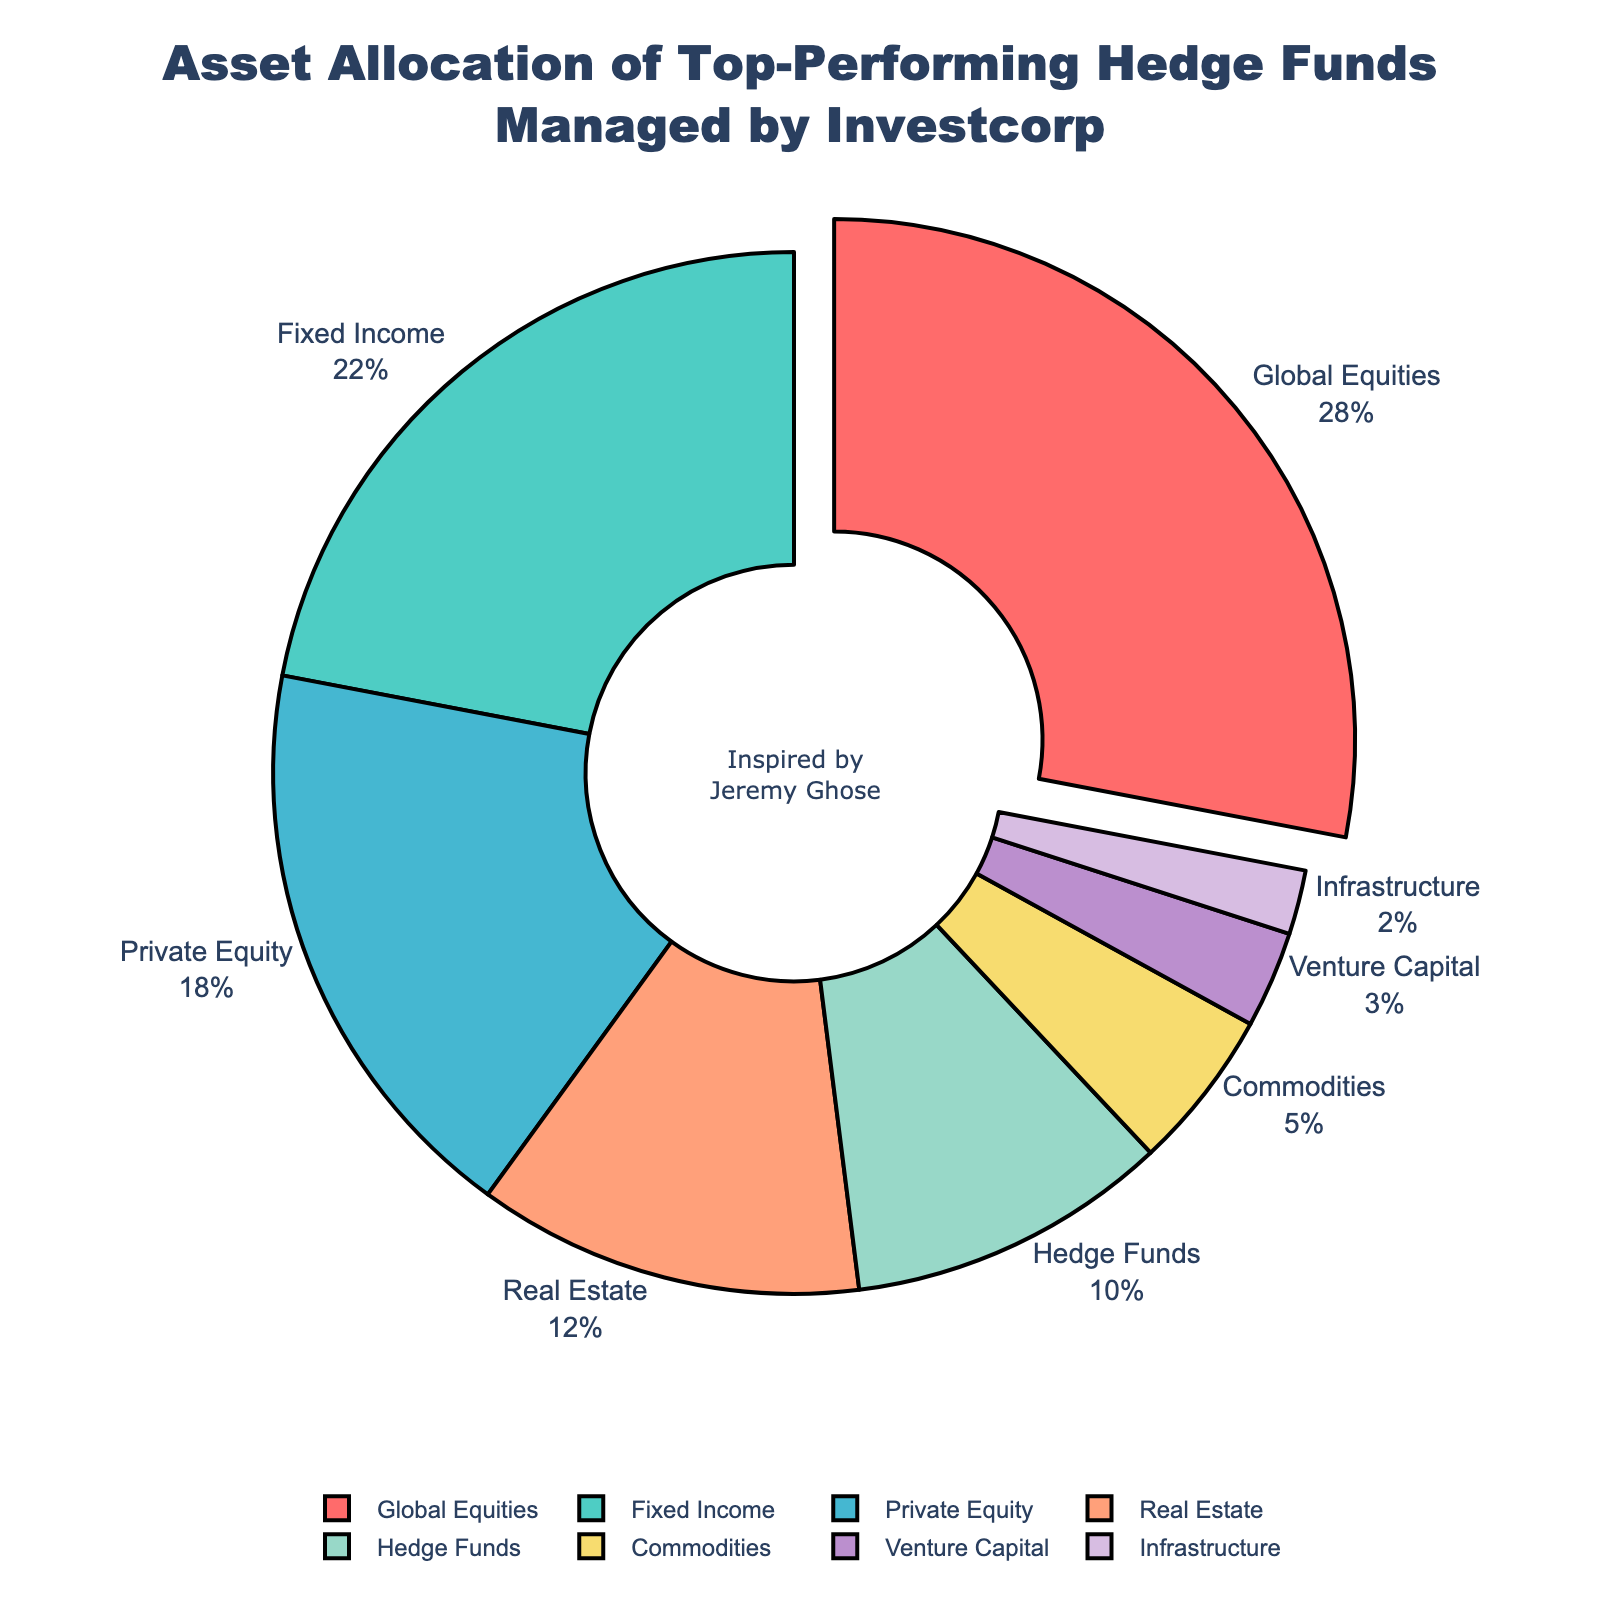What percentage of assets is allocated to the two largest asset classes? The two largest asset classes are Global Equities (28%) and Fixed Income (22%). Adding these percentages gives 28 + 22 = 50%.
Answer: 50% Which asset class has the smallest allocation, and what is the percentage? The smallest allocation is given to Infrastructure, which is 2%.
Answer: Infrastructure, 2% How much more is the percentage allocation to Real Estate than to Commodities? The percentage allocation to Real Estate is 12%, and to Commodities is 5%. The difference is 12 - 5 = 7%.
Answer: 7% Which asset classes are allocated exactly double or more the percentage of Hedge Funds? Hedge Funds are allocated 10%. The asset classes with double or more are Global Equities (28%), Fixed Income (22%), and Private Equity (18%) because all these percentages are more than 20%, which is double 10%.
Answer: Global Equities, Fixed Income, Private Equity Summing the allocations of Venture Capital and Infrastructure, how does it compare to the allocation for Private Equity? Venture Capital is 3% and Infrastructure is 2%, making their sum 3 + 2 = 5%. Private Equity has an allocation of 18%. 5% is less than 18%.
Answer: Less What color represents the asset class with the largest percentage allocation? The pie chart shows that the asset class with the largest allocation is Global Equities, which is represented by the color red.
Answer: Red What is the combined percentage allocation of asset classes other than Global Equities and Fixed Income? Excluding Global Equities (28%) and Fixed Income (22%), the remaining allocations are 18% (Private Equity) + 12% (Real Estate) + 10% (Hedge Funds) + 5% (Commodities) + 3% (Venture Capital) + 2% (Infrastructure) = 50%.
Answer: 50% What is the visual effect applied to indicate the asset class with the largest allocation? The asset class with the largest allocation, which is Global Equities, is pulled out slightly from the rest of the pie chart segments.
Answer: Pulled out Which asset classes have their percentage labels shown outside the pie chart? All asset classes have their percentage labels shown outside the pie chart. This helps in better readability.
Answer: All If the total asset allocation pie chart is scaled to represent a $1 billion portfolio, how much would be allocated to Hedge Funds? Hedge Funds are allocated 10%. Hence, 10% of $1 billion is 0.10 x 1,000,000,000 = $100,000,000.
Answer: $100,000,000 